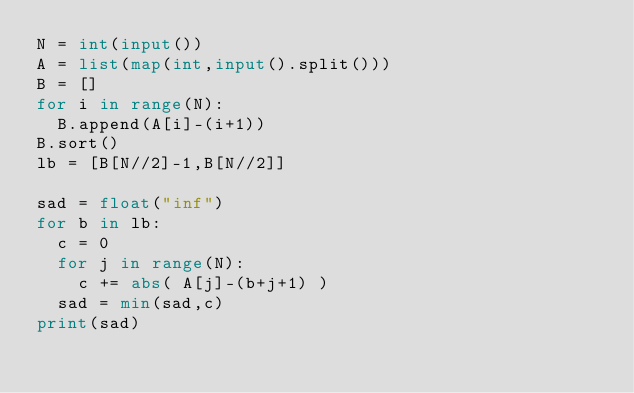Convert code to text. <code><loc_0><loc_0><loc_500><loc_500><_Python_>N = int(input())
A = list(map(int,input().split()))
B = []
for i in range(N):
  B.append(A[i]-(i+1))
B.sort()
lb = [B[N//2]-1,B[N//2]]

sad = float("inf")
for b in lb:
  c = 0
  for j in range(N):
    c += abs( A[j]-(b+j+1) )
  sad = min(sad,c)
print(sad)  </code> 